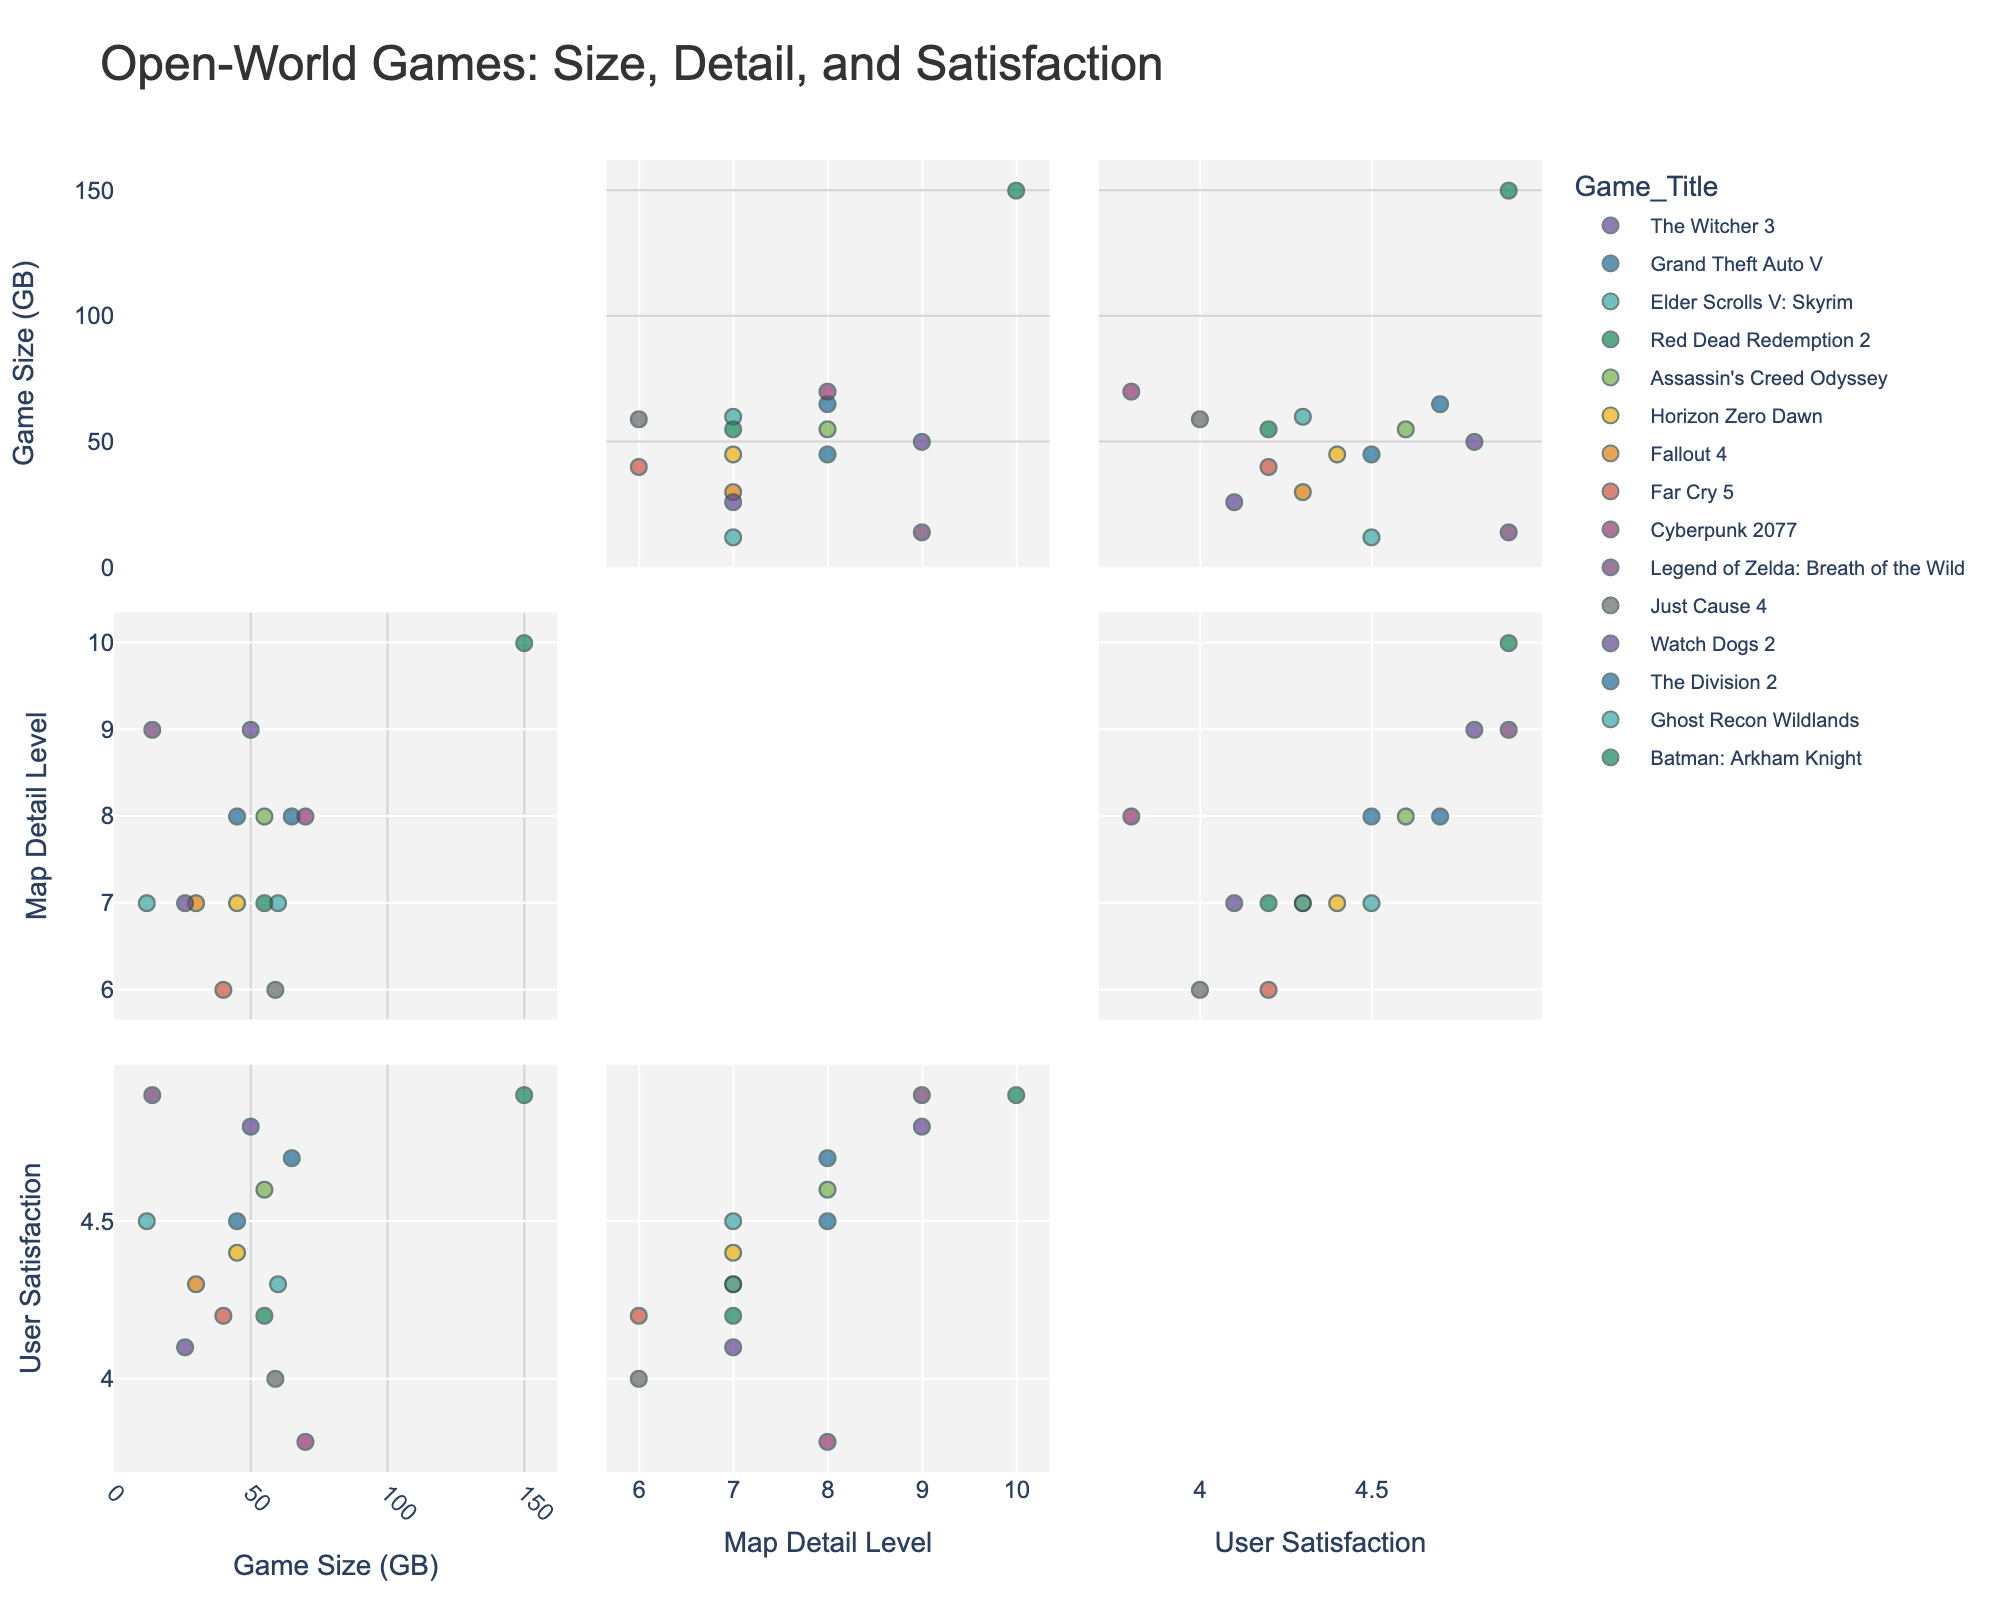What is the title of the figure? The title is prominent and located at the top of the figure. It provides a summary of the visual data displayed.
Answer: Open-World Games: Size, Detail, and Satisfaction How many open-world games are represented in the scatter plot matrix? Each game is represented as a distinct data point, identifiable by color and title. Counting these points will give the total number of games.
Answer: 15 What is the user satisfaction rating of 'Cyberpunk 2077'? Locate the data point labeled 'Cyberpunk 2077' and check its position on the User Satisfaction axis in the relevant plot.
Answer: 3.8 Which game has the highest user satisfaction rating? Find the data point that reaches the highest position on the User Satisfaction axis across all subplots.
Answer: Legend of Zelda: Breath of the Wild Do larger-sized games tend to have higher map detail levels? Examine the scatter plots where 'Game Size (GB)' and 'Map Detail Level' are plotted against each other to see if a trend or pattern indicates a correlation.
Answer: Yes, generally What are the average game size and user satisfaction rating for games with a map detail level of 7? Identify the data points where 'Map Detail Level' is 7, then calculate the mean of 'Game Size (GB)' and 'User Satisfaction' for those points.
Answer: Game Size: 34.3 GB, User Satisfaction: 4.3 Compare the user satisfaction ratings of 'The Witcher 3' and 'Grand Theft Auto V'. Which one is higher? Find the data points for both games in the subplots and compare their positions on the User Satisfaction axis.
Answer: The Witcher 3 Which game has the largest game size, and what is its user satisfaction rating? Find the data point farthest along on the 'Game Size (GB)' axis and note its position on the User Satisfaction axis.
Answer: Red Dead Redemption 2, 4.9 Is there any game with the same user satisfaction rating but different map detail levels? If yes, name one. Look for data points aligned on the User Satisfaction axis but differing on the 'Map Detail Level' axis in the corresponding subplots.
Answer: Yes, Elder Scrolls V: Skyrim and The Division 2 (both 4.5) How does the user satisfaction rating of 'Watch Dogs 2' compare to 'Far Cry 5'? Find and compare the positions of 'Watch Dogs 2' and 'Far Cry 5' on the User Satisfaction axis.
Answer: Watch Dogs 2 is slightly lower 